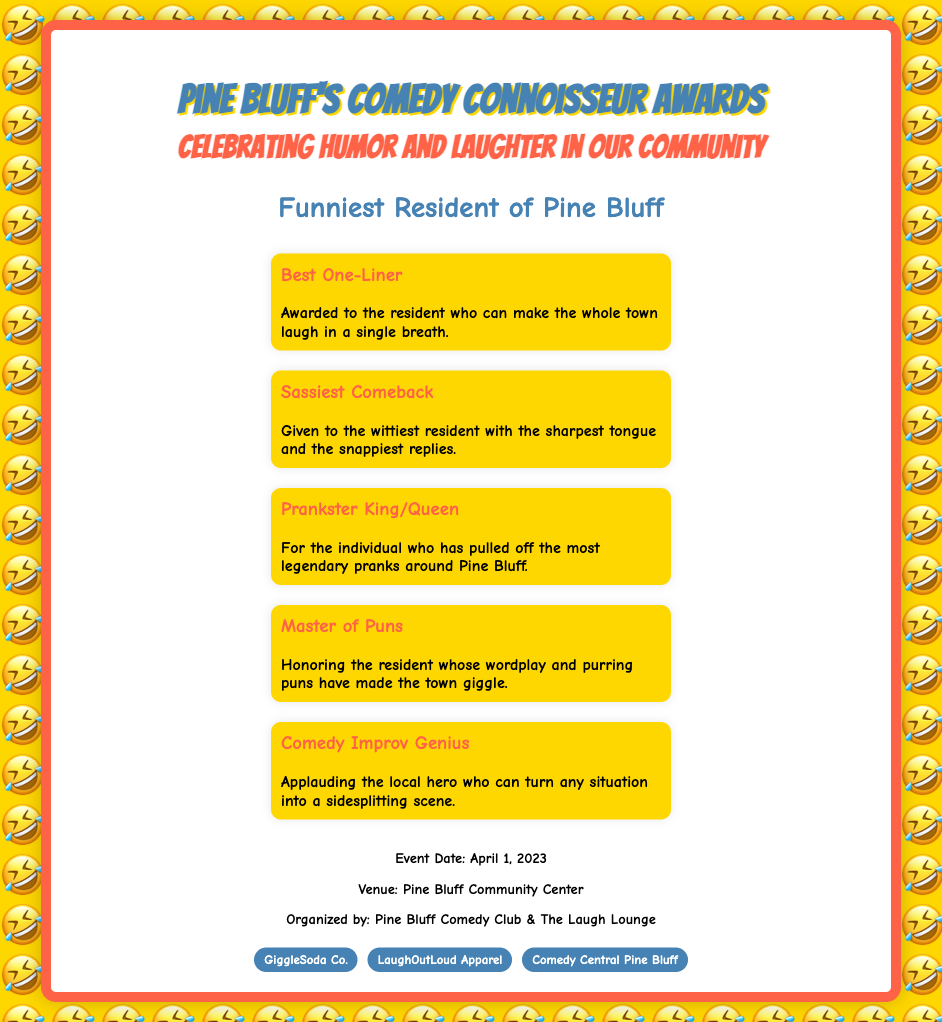What is the title of the award? The title of the award is prominently displayed in the document under the award name section.
Answer: Funniest Resident of Pine Bluff Who organized the event? The document contains information regarding the organizing bodies at the bottom in the additional info section.
Answer: Pine Bluff Comedy Club & The Laugh Lounge What date was the event held? The date of the event is listed in the additional information section of the document.
Answer: April 1, 2023 Which category recognizes the best jokes delivered in a single line? The specific category is detailed within the categories section of the document.
Answer: Best One-Liner What is the background color of the certificate? The background color is specified in the document style section.
Answer: White How many categories are listed in the document? The document includes a section detailing multiple comedy categories, which can be counted.
Answer: Five What venue hosted the award ceremony? The venue for the event is indicated in the additional information section.
Answer: Pine Bluff Community Center Which category aims to honor the resident good at light-hearted wordplay? This category is specifically named within the categories section of the document.
Answer: Master of Puns 